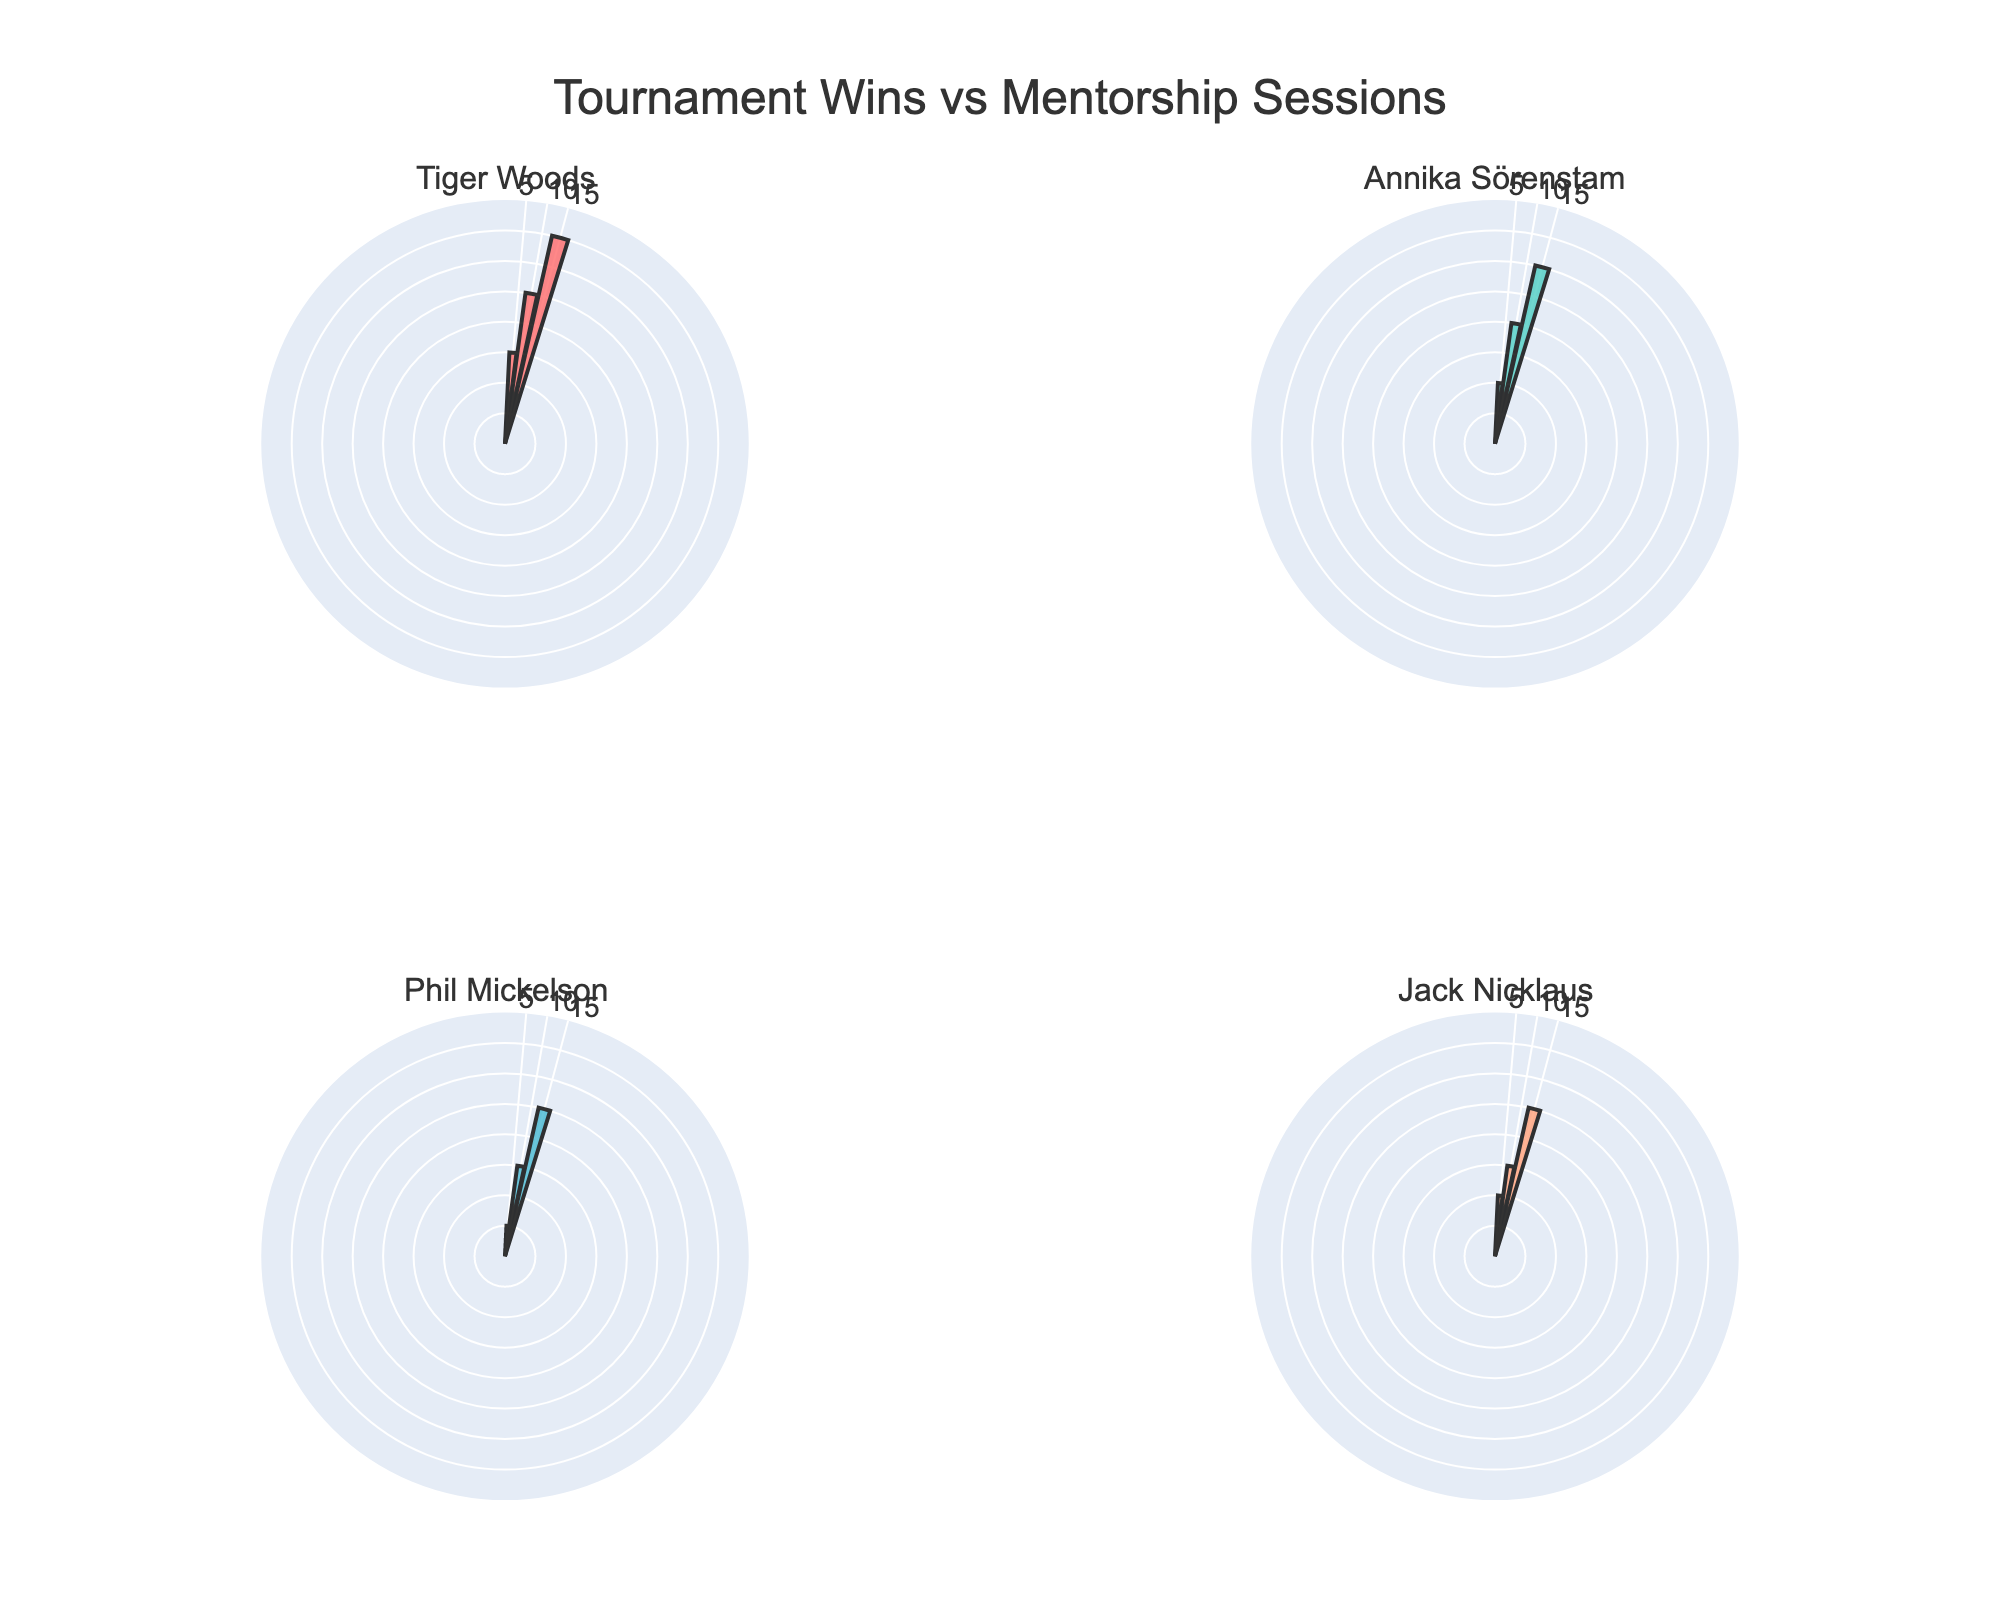What is the title of the figure? The title of the figure is typically displayed at the top. By viewing this figure, we can see the text “Tournament Wins vs Mentorship Sessions” prominently displayed.
Answer: Tournament Wins vs Mentorship Sessions Which mentor had the highest number of tournament wins after 5 sessions? To identify the mentor with the highest number of tournament wins after 5 sessions, we should look at the segment for each mentor's subplot corresponding to 5 sessions. Tiger Woods had 3 wins, Annika Sörenstam had 2 wins, Phil Mickelson had 1 win, and Jack Nicklaus had 2 wins. Tiger Woods had the highest number of wins.
Answer: Tiger Woods What's the sum of tournament wins for Tiger Woods across all session counts? We need to sum the number of tournament wins for Tiger Woods at all session counts. According to the data, his tournament wins are 3 (for 5 sessions), 5 (for 10 sessions), and 7 (for 15 sessions). Summing these up: 3 + 5 + 7 = 15.
Answer: 15 Which mentor shows a consistent increase in tournament wins with more mentorship sessions? By comparing the number of tournament wins as session counts increase for each mentor, we see that Tiger Woods (3 to 5 to 7), Annika Sörenstam (2 to 4 to 6), and Phil Mickelson (1 to 3 to 5) all show a consistent increase. Jack Nicklaus's wins (2 to 3 to 5) also show a consistent increase. No mentor's tournament wins decrease; they all increase consistently.
Answer: All mentors How many tournament wins did Annika Sörenstam and Phil Mickelson achieve across 10 sessions combined? We need to add the total tournament wins of Annika Sörenstam and Phil Mickelson at 10 sessions each. Annika Sörenstam had 4 wins, and Phil Mickelson had 3 wins at this session count. Therefore, combined, it's 4 + 3 = 7.
Answer: 7 Which mentor has the smallest range of tournament wins across the session counts? Range is calculated as the difference between the maximum and minimum number of wins. For Tiger Woods (7 - 3 = 4), Annika Sörenstam (6 - 2 = 4), Phil Mickelson (5 - 1 = 4), Jack Nicklaus (5 - 2 = 3). Jack Nicklaus has the smallest range of tournament wins across the session counts.
Answer: Jack Nicklaus What's the average number of tournament wins for mentorship sessions of 15 across all mentors? To find the average number of tournament wins for 15 sessions, sum the wins at 15 sessions from all mentors and divide by the number of mentors. The wins are Tiger Woods (7), Annika Sörenstam (6), Phil Mickelson (5), and Jack Nicklaus (5). So (7 + 6 + 5 + 5) / 4 = 23 / 4 = 5.75.
Answer: 5.75 What is the difference in tournament wins between the mentor with the highest and the lowest wins at 10 sessions? We look at the tournament wins for each mentor at 10 sessions: Tiger Woods (5), Annika Sörenstam (4), Phil Mickelson (3), and Jack Nicklaus (3). The highest is 5, and the lowest is 3. The difference is 5 - 3 = 2.
Answer: 2 